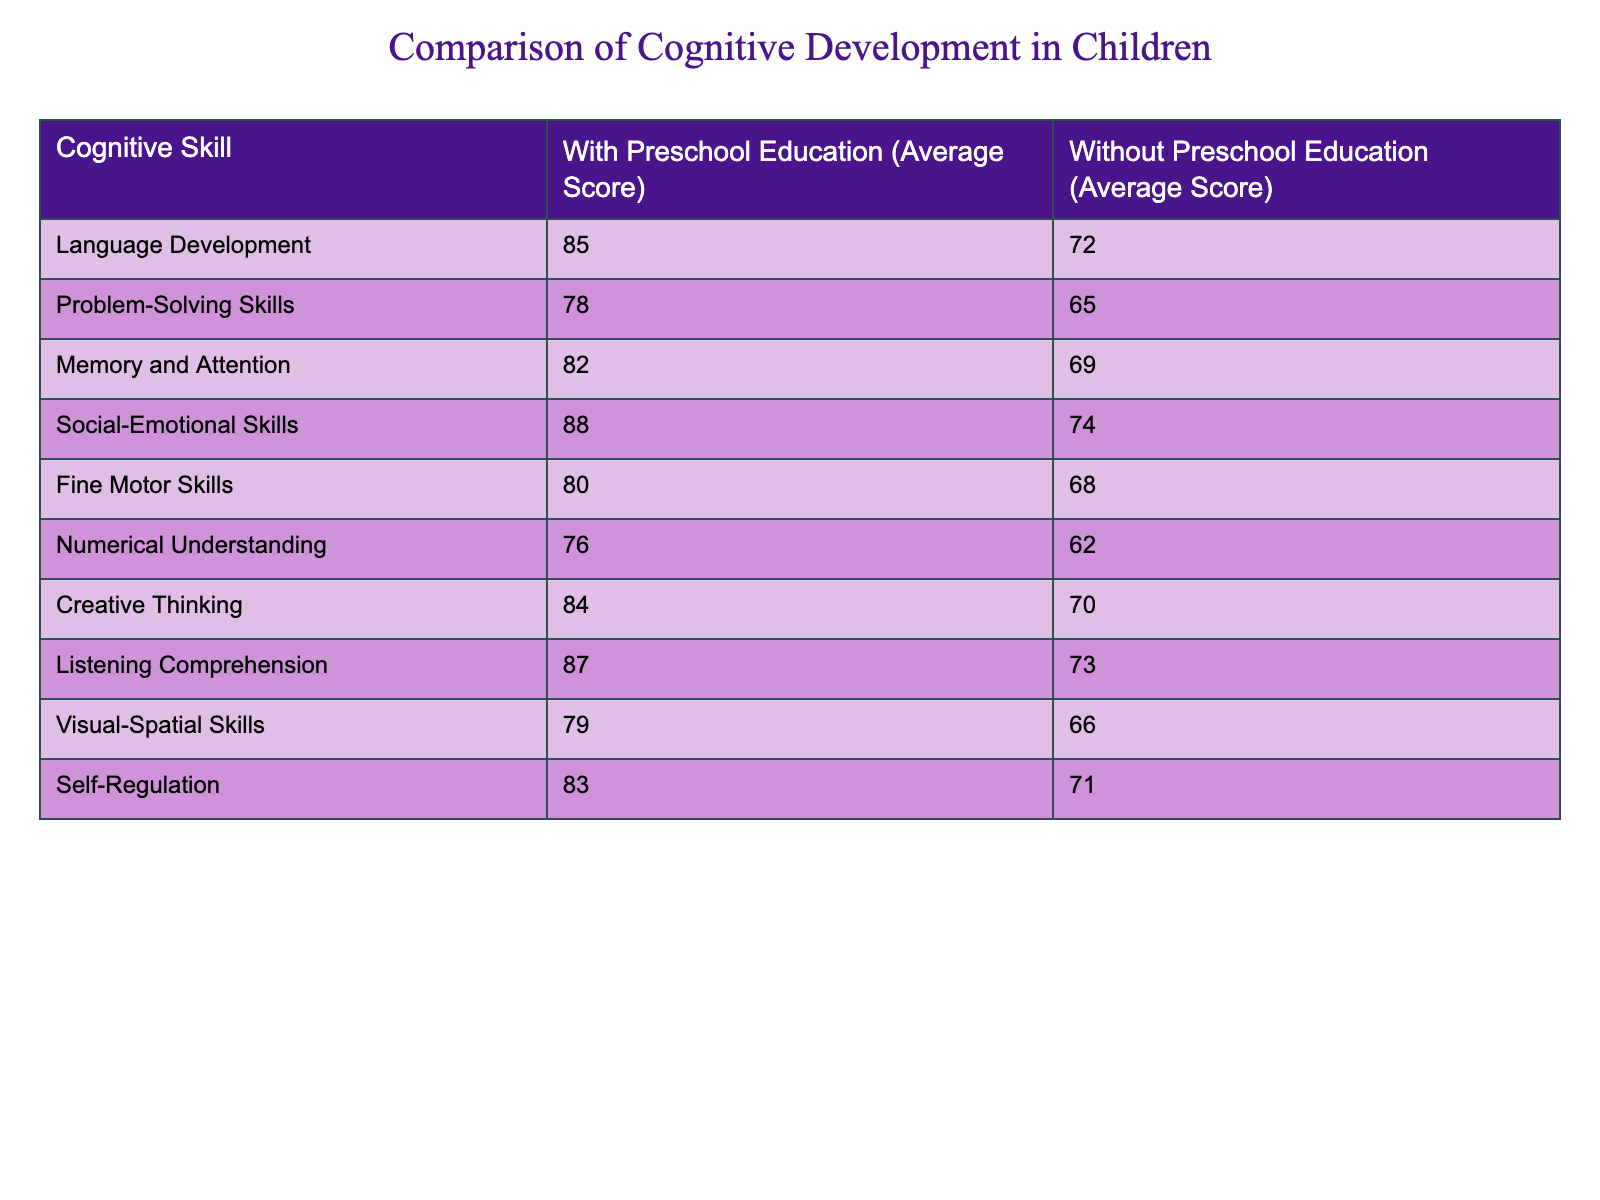What is the average score for language development in children with preschool education? The table shows that the average score for language development in the group with preschool education is 85.
Answer: 85 What is the average score for problem-solving skills in children without preschool education? According to the table, the average score for problem-solving skills for the group without preschool education is 65.
Answer: 65 Which cognitive skill has the highest score for children with preschool education? The table indicates that social-emotional skills have the highest score at 88 for the group with preschool education.
Answer: 88 What is the difference in average scores for fine motor skills between children with and without preschool education? The score for fine motor skills with preschool education is 80, while for those without is 68. The difference is 80 - 68 = 12.
Answer: 12 What is the average score for self-regulation skills in children with preschool education? The average score for self-regulation in children with preschool education, according to the table, is 83.
Answer: 83 True or false: Children without preschool education scored higher on visual-spatial skills than those with preschool education. The scores show that children with preschool education scored 79, while those without scored 66. Thus, the statement is false.
Answer: False What are the average scores for numerical understanding in both groups, and what is their difference? The score for numerical understanding with preschool education is 76, while without it is 62. The difference is 76 - 62 = 14.
Answer: 14 What is the sum of the average scores for memory and attention in both groups? The average score for memory and attention with preschool education is 82 and without is 69. The sum is 82 + 69 = 151.
Answer: 151 Which cognitive skill shows the largest gap in average scores between children with and without preschool education? By comparing the differences for each skill, social-emotional skills have the largest gap at 14 (88 - 74).
Answer: Social-Emotional Skills What would be the average score for listening comprehension if we combined both groups' scores? The average score for listening comprehension for the group with preschool education is 87 and for the group without is 73. The combined average is (87 + 73) / 2 = 80.
Answer: 80 